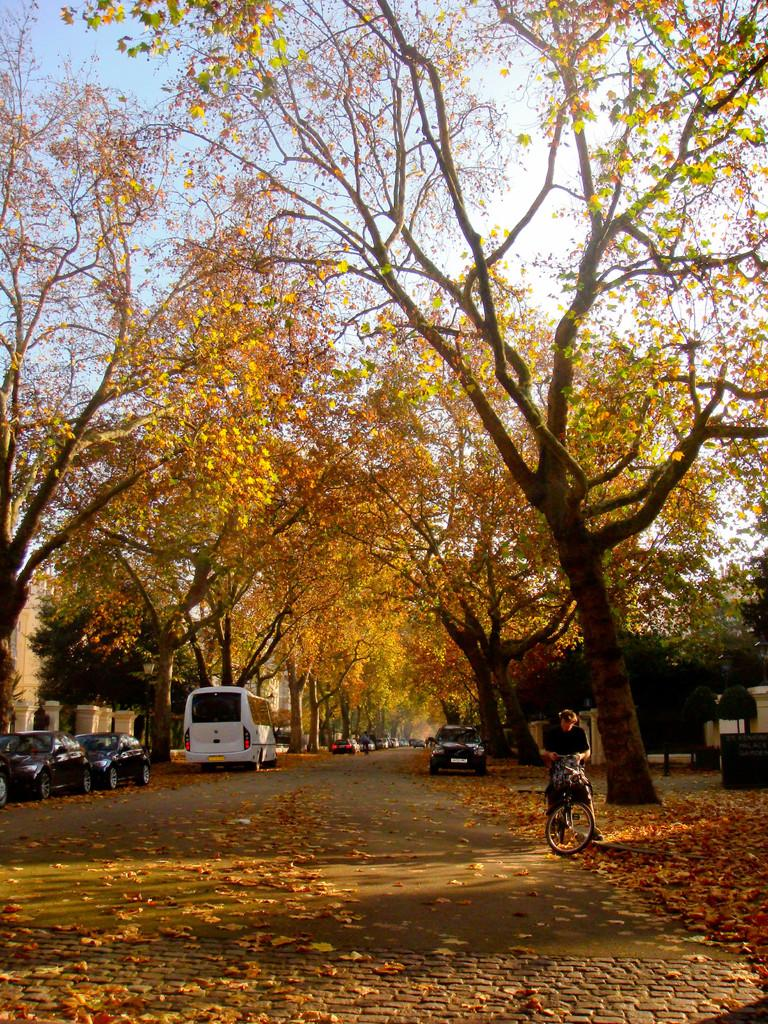What types of vehicles can be seen in the image? There are cars and buses in the image. Where are the vehicles located? The vehicles are on the road in the image. What else can be seen on either side of the road? Trees are present on either side of the road in the image. Is there anyone else besides the drivers of the vehicles in the image? Yes, there is a person on a bicycle in the image. What can be seen in the sky in the image? The sky is visible in the image. What type of cushion is being used by the doctor in the image? There is no doctor or cushion present in the image. How many pears can be seen in the image? There are no pears present in the image. 